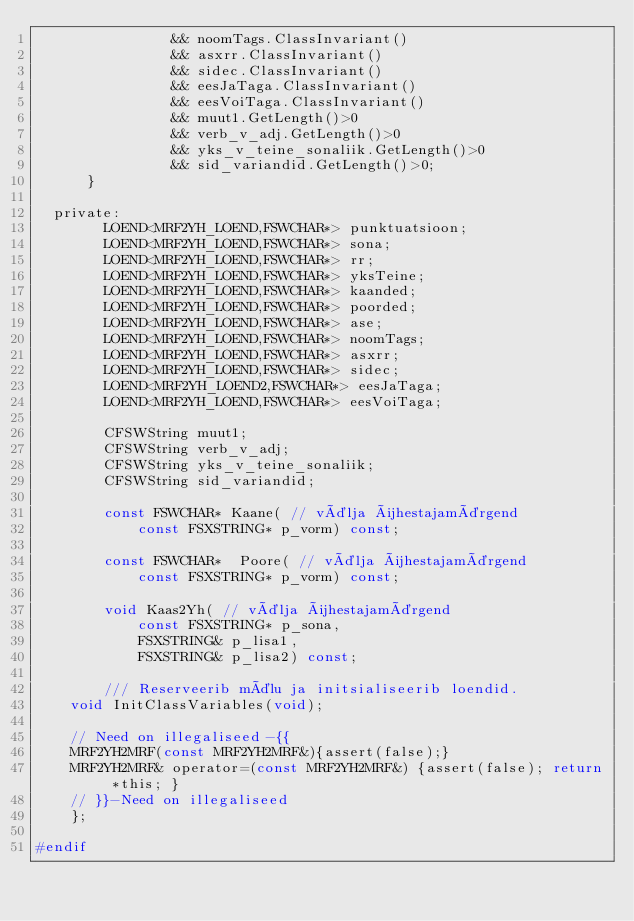<code> <loc_0><loc_0><loc_500><loc_500><_C_>                && noomTags.ClassInvariant()
                && asxrr.ClassInvariant()
                && sidec.ClassInvariant()
                && eesJaTaga.ClassInvariant()
                && eesVoiTaga.ClassInvariant()
                && muut1.GetLength()>0
                && verb_v_adj.GetLength()>0
                && yks_v_teine_sonaliik.GetLength()>0
                && sid_variandid.GetLength()>0;
			}

	private:
        LOEND<MRF2YH_LOEND,FSWCHAR*> punktuatsioon;
        LOEND<MRF2YH_LOEND,FSWCHAR*> sona;
        LOEND<MRF2YH_LOEND,FSWCHAR*> rr;
        LOEND<MRF2YH_LOEND,FSWCHAR*> yksTeine;
        LOEND<MRF2YH_LOEND,FSWCHAR*> kaanded;
        LOEND<MRF2YH_LOEND,FSWCHAR*> poorded;
        LOEND<MRF2YH_LOEND,FSWCHAR*> ase;
        LOEND<MRF2YH_LOEND,FSWCHAR*> noomTags;
        LOEND<MRF2YH_LOEND,FSWCHAR*> asxrr;
        LOEND<MRF2YH_LOEND,FSWCHAR*> sidec;
        LOEND<MRF2YH_LOEND2,FSWCHAR*> eesJaTaga;
        LOEND<MRF2YH_LOEND,FSWCHAR*> eesVoiTaga;

        CFSWString muut1;
        CFSWString verb_v_adj;
        CFSWString yks_v_teine_sonaliik;
        CFSWString sid_variandid;

        const FSWCHAR* Kaane( // välja ühestajamärgend
            const FSXSTRING* p_vorm) const;

        const FSWCHAR*  Poore( // välja ühestajamärgend
            const FSXSTRING* p_vorm) const;

        void Kaas2Yh( // välja ühestajamärgend
            const FSXSTRING* p_sona,
            FSXSTRING& p_lisa1,
            FSXSTRING& p_lisa2) const;

        /// Reserveerib mälu ja initsialiseerib loendid.
		void InitClassVariables(void);

		// Need on illegaliseed-{{
		MRF2YH2MRF(const MRF2YH2MRF&){assert(false);} 
		MRF2YH2MRF& operator=(const MRF2YH2MRF&) {assert(false); return *this; }
		// }}-Need on illegaliseed
    };

#endif


</code> 